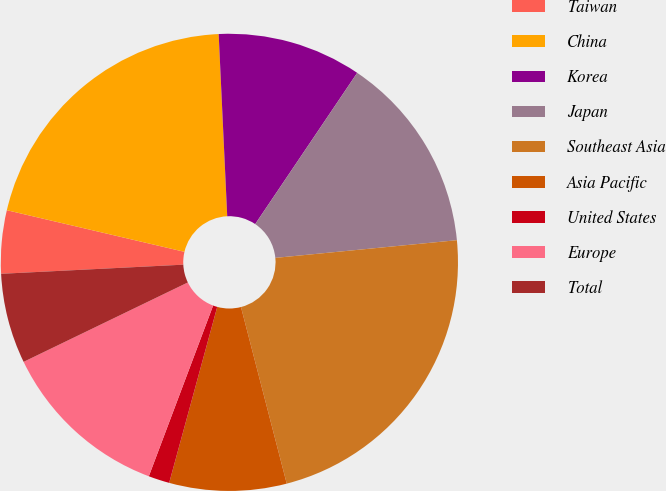<chart> <loc_0><loc_0><loc_500><loc_500><pie_chart><fcel>Taiwan<fcel>China<fcel>Korea<fcel>Japan<fcel>Southeast Asia<fcel>Asia Pacific<fcel>United States<fcel>Europe<fcel>Total<nl><fcel>4.46%<fcel>20.59%<fcel>10.19%<fcel>14.01%<fcel>22.51%<fcel>8.28%<fcel>1.49%<fcel>12.1%<fcel>6.37%<nl></chart> 